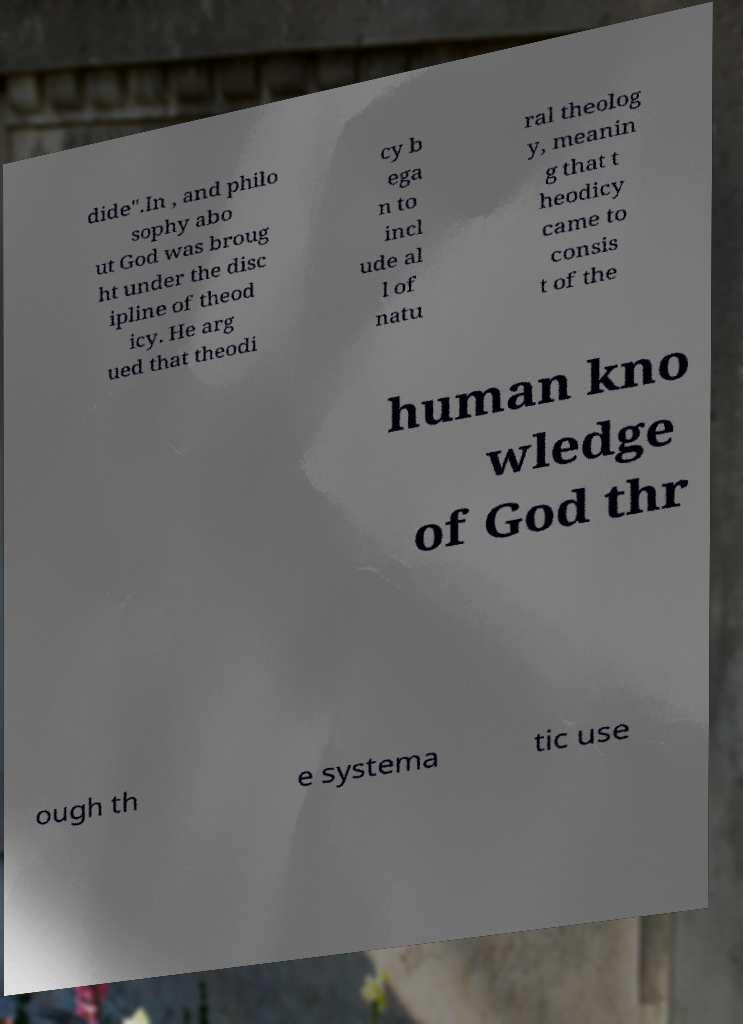Can you accurately transcribe the text from the provided image for me? dide".In , and philo sophy abo ut God was broug ht under the disc ipline of theod icy. He arg ued that theodi cy b ega n to incl ude al l of natu ral theolog y, meanin g that t heodicy came to consis t of the human kno wledge of God thr ough th e systema tic use 